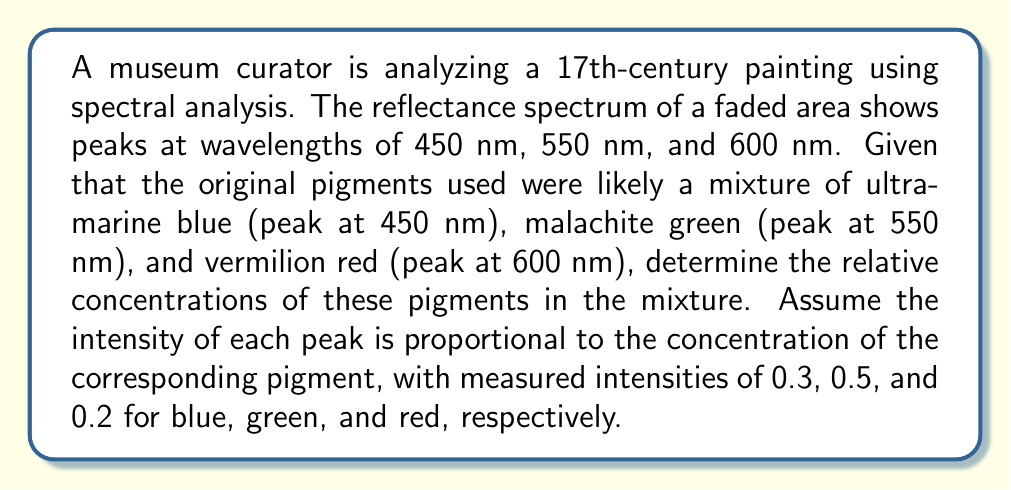Give your solution to this math problem. To solve this inverse problem and determine the original pigment composition, we'll follow these steps:

1. Identify the given information:
   - Ultramarine blue: peak at 450 nm, intensity 0.3
   - Malachite green: peak at 550 nm, intensity 0.5
   - Vermilion red: peak at 600 nm, intensity 0.2

2. Calculate the total intensity:
   $$ I_{total} = 0.3 + 0.5 + 0.2 = 1.0 $$

3. Calculate the relative concentration of each pigment:
   
   For ultramarine blue:
   $$ C_{blue} = \frac{0.3}{1.0} = 0.3 = 30\% $$
   
   For malachite green:
   $$ C_{green} = \frac{0.5}{1.0} = 0.5 = 50\% $$
   
   For vermilion red:
   $$ C_{red} = \frac{0.2}{1.0} = 0.2 = 20\% $$

4. Express the relative concentrations as a ratio:
   $$ C_{blue} : C_{green} : C_{red} = 30 : 50 : 20 = 3 : 5 : 2 $$

This ratio represents the relative concentrations of the original pigments in the mixture.
Answer: 3:5:2 